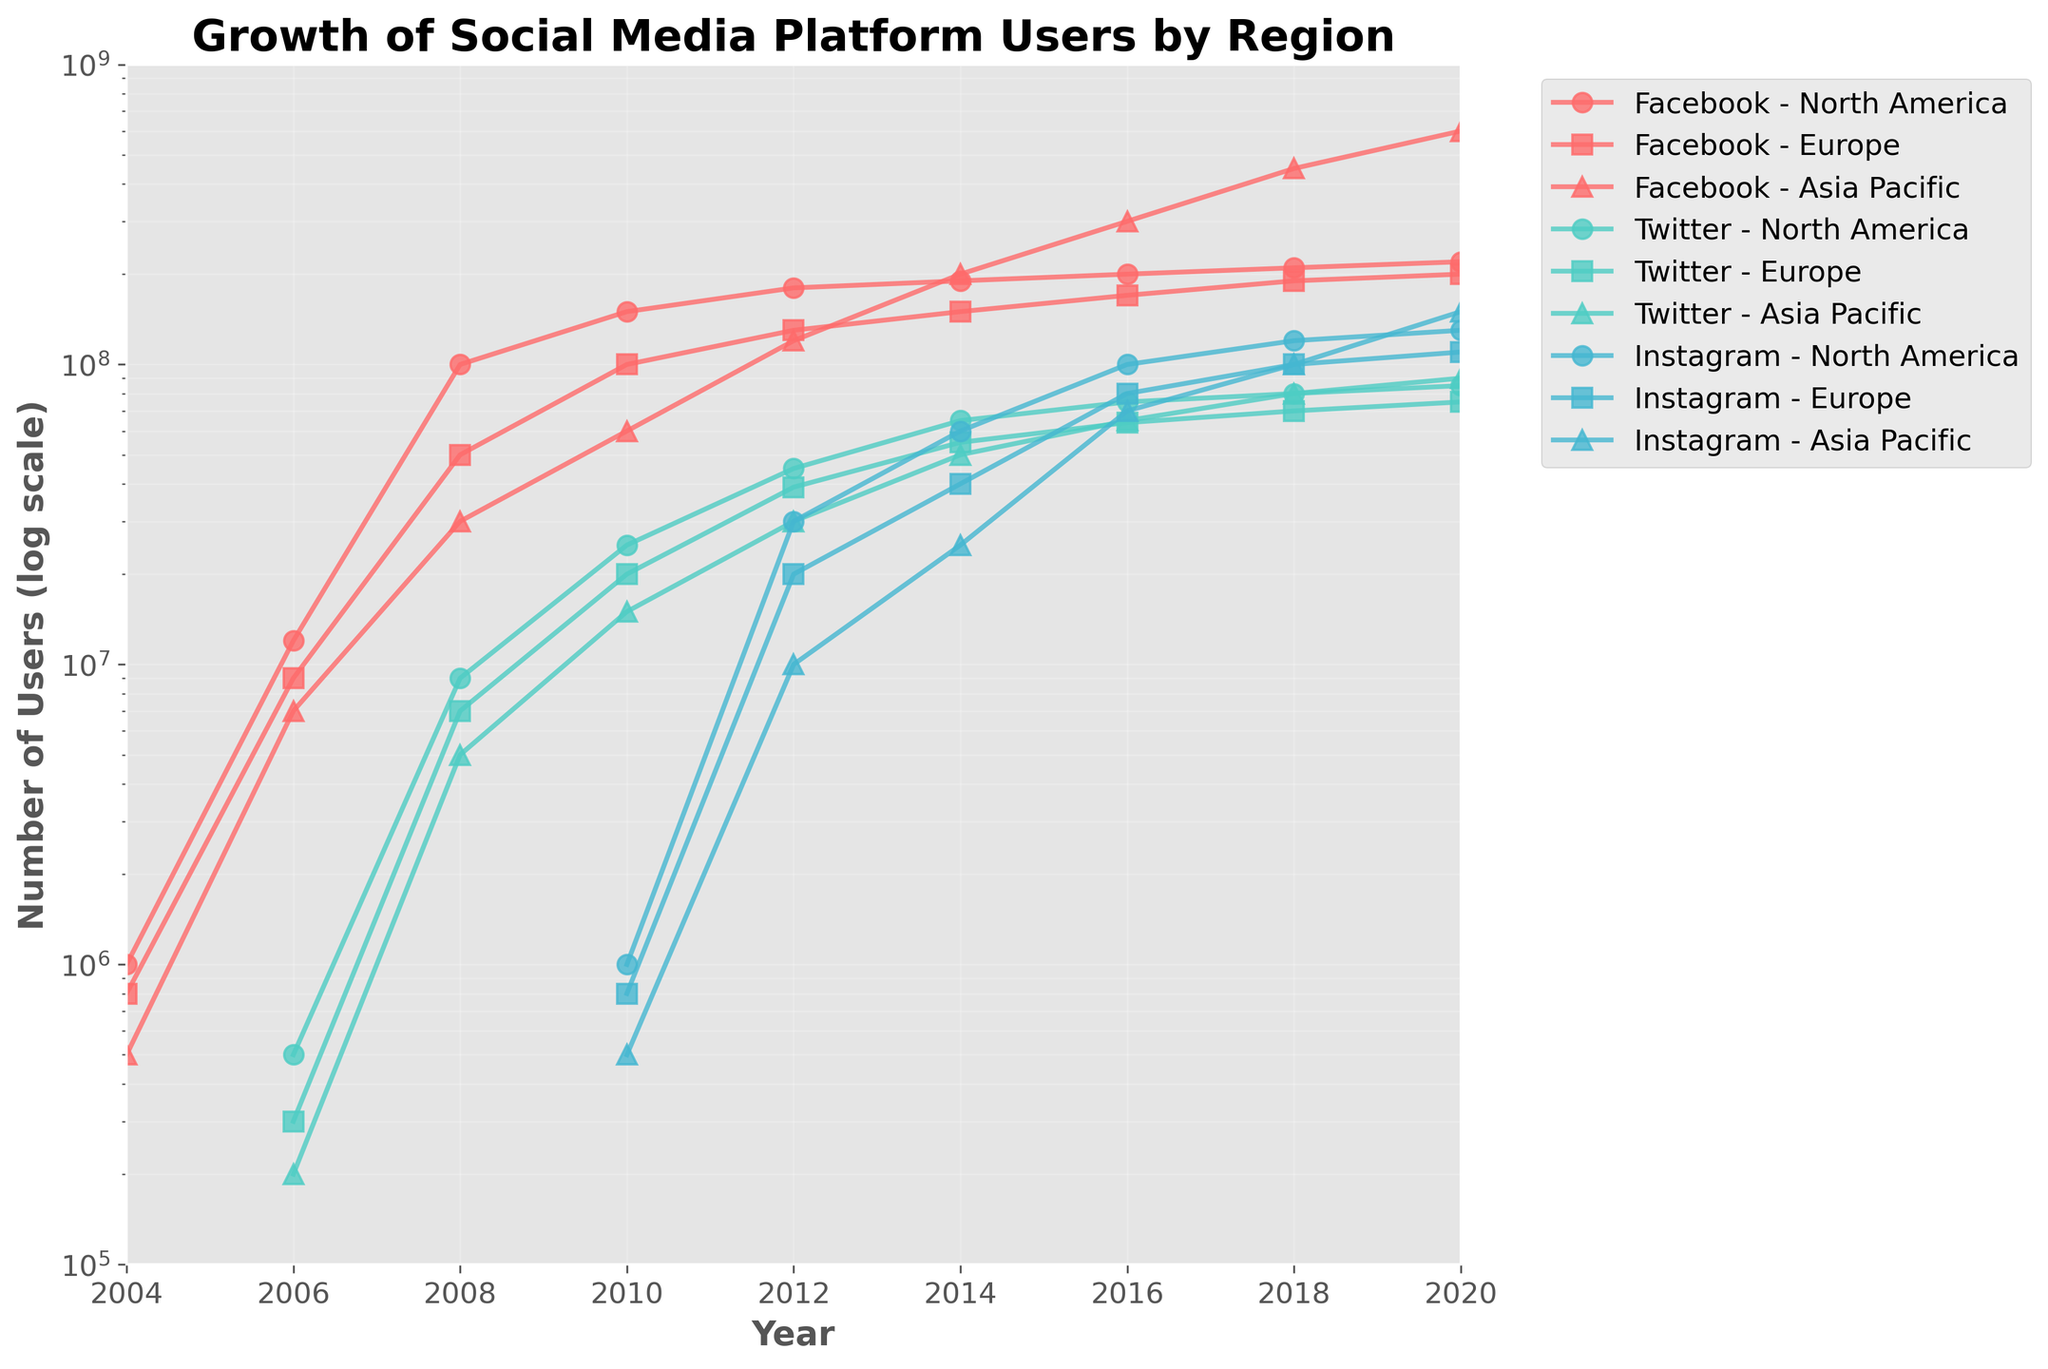What's the title of the figure? The title of the figure is shown at the top, and it provides a summary of what the figure represents. The title reads: "Growth of Social Media Platform Users by Region".
Answer: Growth of Social Media Platform Users by Region How is the y-axis scaled in the figure? The y-axis is scaled logarithmically, which allows for a wide range of values to be represented in a compressed manner. This is indicated by the label "Number of Users (log scale)" and the spacing of the ticks on the y-axis.
Answer: Logarithmically Which platform had the highest number of users in the Asia Pacific region in 2020? By observing the plot lines representing the Asia Pacific region in 2020, we can see that Facebook has the highest number of users. This is evident by the highest point along the y-axis at the 2020 mark for the Asia Pacific region.
Answer: Facebook Between 2012 and 2016, which region saw the biggest growth in Instagram users? We need to compare the growth in Instagram users across different regions. By looking at the increase in y-axis values for North America, Europe, and Asia Pacific from 2012 to 2016, Asia Pacific shows the largest increase, growing from around 10 million to approximately 70 million users.
Answer: Asia Pacific Which social media platform shows a consistent increase in users across all regions from its inception to 2020? By examining the plot lines for all platforms across all regions, we see that Facebook consistently increases in user numbers without any decline, leading to substantial growth over time.
Answer: Facebook In 2008, which platform had more users in Europe, Twitter or Instagram? By locating the points for Europe in 2008 on the plot, we see that Instagram does not have any data for that year, whereas Twitter does, with significant users noted around the 7 million mark. Therefore, Twitter had more users in Europe in 2008.
Answer: Twitter What was the approximate number of Instagram users in North America in 2018? Locate the plot line for Instagram in the North America region for the year 2018. The number of users is around 120 million, as marked on the y-axis.
Answer: 120 million Rank the three platforms by their user base in the Asia Pacific region in 2020 from highest to lowest. Check the endpoints of the plot lines for Facebook, Twitter, and Instagram in the Asia Pacific region for the year 2020. Facebook leads with around 600 million users, followed by Instagram with approximately 150 million, and Twitter with around 90 million.
Answer: Facebook, Instagram, Twitter By how much did Facebook users in Europe increase from 2004 to 2020? Find the difference in the number of users from 2004 to 2020 for Facebook in Europe. In 2004, it was 800,000 users, and by 2020, it rose to 200 million. The increase is 200 million - 800,000 = 199.2 million.
Answer: 199.2 million Does Twitter or Instagram have a higher user growth rate in North America from 2006 to 2016? Examine the slope of the plot lines for Twitter and Instagram between 2006 and 2016 in North America. Twitter starts at around 500,000 users in 2006 and grows to 75 million in 2016. Instagram starts at 1 million in 2010 and grows to 100 million by 2016, indicating a sharper increase. Thus, Instagram has a higher growth rate.
Answer: Instagram 